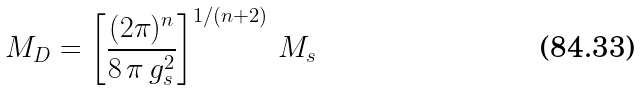Convert formula to latex. <formula><loc_0><loc_0><loc_500><loc_500>M _ { D } = \left [ \frac { ( 2 \pi ) ^ { n } } { 8 \, \pi \, g _ { s } ^ { 2 } } \right ] ^ { 1 / ( n + 2 ) } \, M _ { s }</formula> 